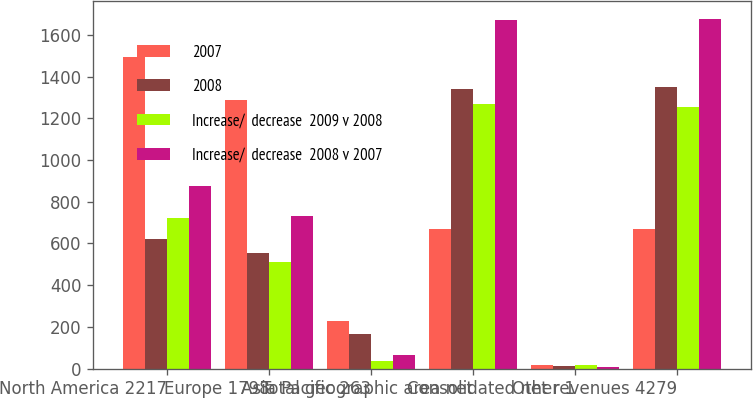Convert chart. <chart><loc_0><loc_0><loc_500><loc_500><stacked_bar_chart><ecel><fcel>North America 2217<fcel>Europe 1798<fcel>Asia Pacific 263<fcel>Total geographic area net<fcel>Other 1<fcel>Consolidated net revenues 4279<nl><fcel>2007<fcel>1494<fcel>1288<fcel>227<fcel>671.5<fcel>17<fcel>671.5<nl><fcel>2008<fcel>620<fcel>555<fcel>164<fcel>1339<fcel>10<fcel>1349<nl><fcel>Increase/  decrease  2009 v 2008<fcel>723<fcel>510<fcel>36<fcel>1269<fcel>16<fcel>1253<nl><fcel>Increase/  decrease  2008 v 2007<fcel>874<fcel>733<fcel>63<fcel>1670<fcel>7<fcel>1677<nl></chart> 